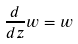<formula> <loc_0><loc_0><loc_500><loc_500>\frac { d } { d z } w = w</formula> 